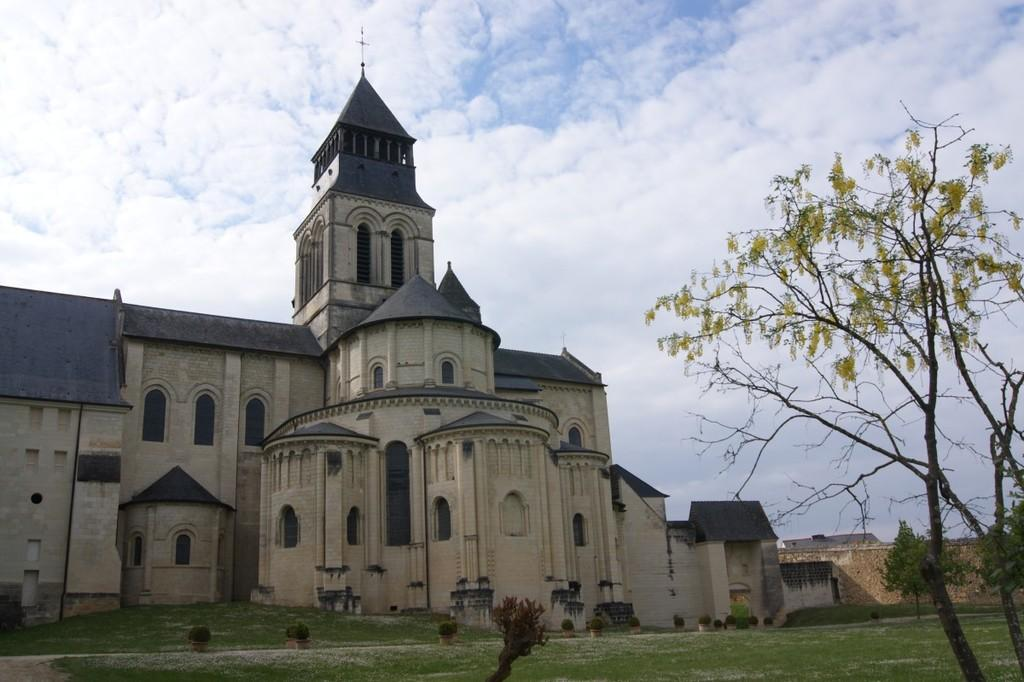What is the main structure in the image? There is a building in the image. What feature can be seen on the building? The building has a group of windows. What can be seen in the background of the image? There is a group of trees in the background of the image. How would you describe the sky in the image? The sky is cloudy in the background of the image. What type of teeth can be seen on the building in the image? There are no teeth present on the building in the image. 